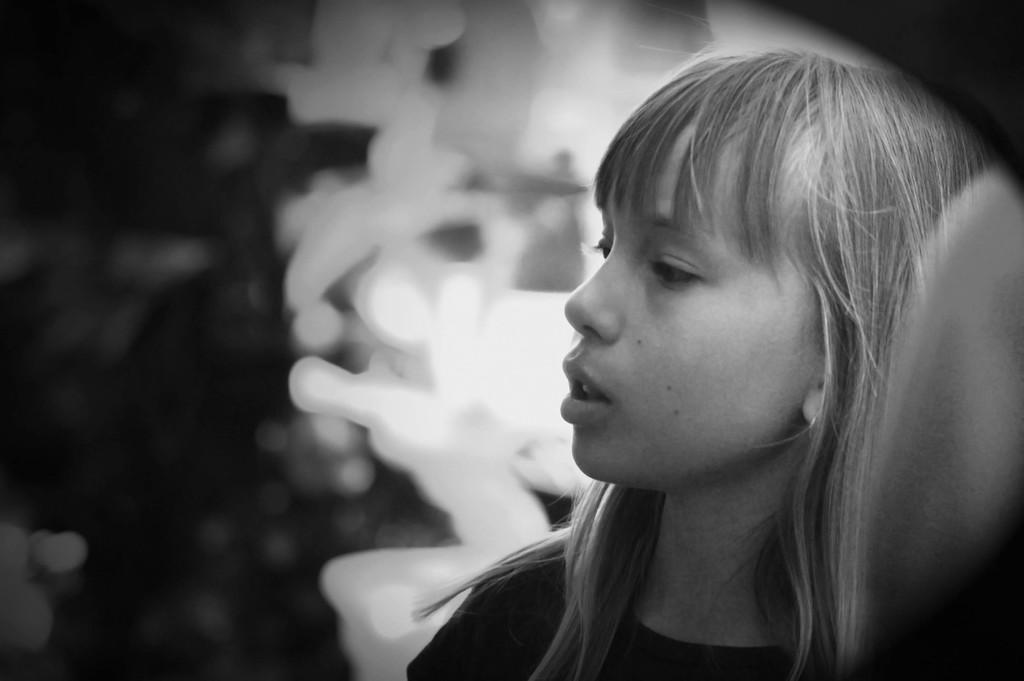What is the color scheme of the image? The image is black and white. Who or what is the main subject in the image? There is a girl in the image. Where is the girl located in the image? The girl is on the right side of the image. Can you describe the background of the image? The background of the image is blurred. What type of hill can be seen in the background of the image? There is no hill visible in the background of the image, as the background is blurred. How many knots are tied in the girl's hair in the image? There is no information about the girl's hair or any knots in the provided facts, so we cannot answer this question. 